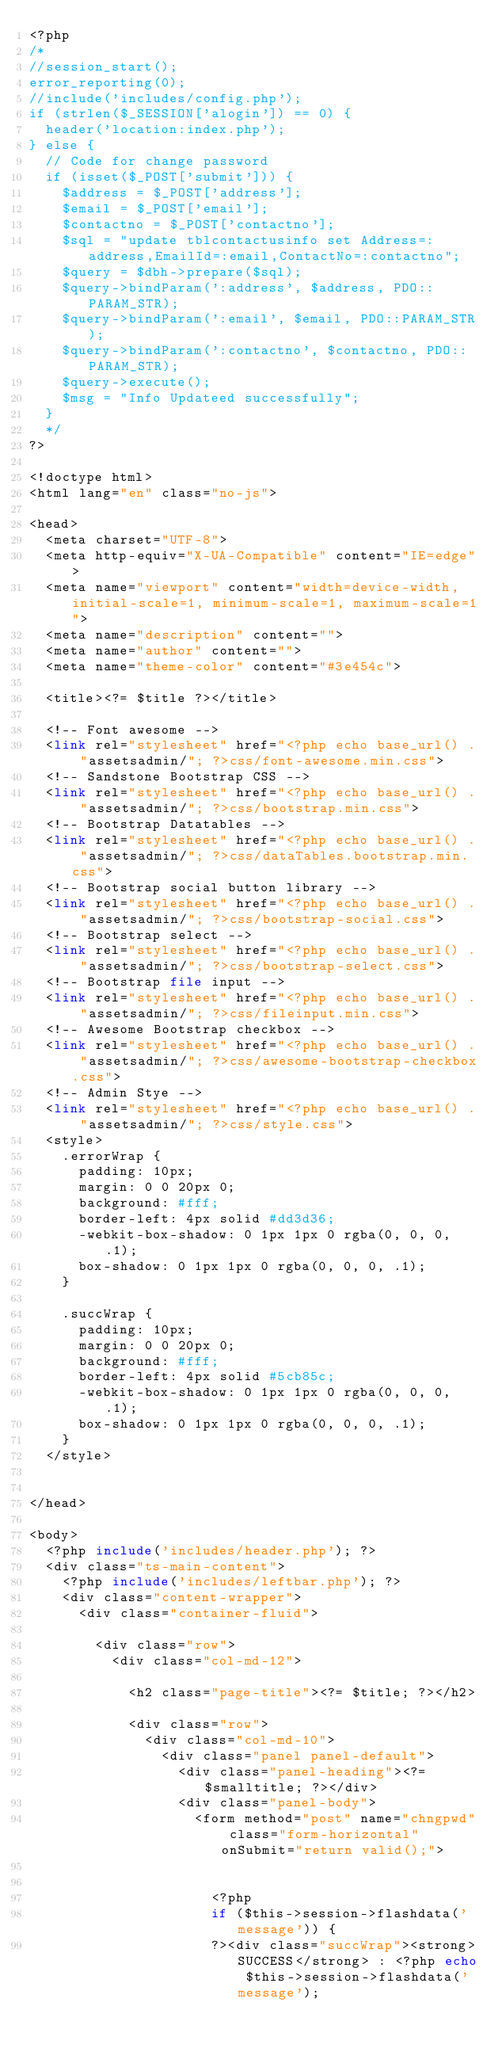Convert code to text. <code><loc_0><loc_0><loc_500><loc_500><_PHP_><?php
/*
//session_start();
error_reporting(0);
//include('includes/config.php');
if (strlen($_SESSION['alogin']) == 0) {
	header('location:index.php');
} else {
	// Code for change password	
	if (isset($_POST['submit'])) {
		$address = $_POST['address'];
		$email = $_POST['email'];
		$contactno = $_POST['contactno'];
		$sql = "update tblcontactusinfo set Address=:address,EmailId=:email,ContactNo=:contactno";
		$query = $dbh->prepare($sql);
		$query->bindParam(':address', $address, PDO::PARAM_STR);
		$query->bindParam(':email', $email, PDO::PARAM_STR);
		$query->bindParam(':contactno', $contactno, PDO::PARAM_STR);
		$query->execute();
		$msg = "Info Updateed successfully";
	}
	*/
?>

<!doctype html>
<html lang="en" class="no-js">

<head>
	<meta charset="UTF-8">
	<meta http-equiv="X-UA-Compatible" content="IE=edge">
	<meta name="viewport" content="width=device-width, initial-scale=1, minimum-scale=1, maximum-scale=1">
	<meta name="description" content="">
	<meta name="author" content="">
	<meta name="theme-color" content="#3e454c">

	<title><?= $title ?></title>

	<!-- Font awesome -->
	<link rel="stylesheet" href="<?php echo base_url() . "assetsadmin/"; ?>css/font-awesome.min.css">
	<!-- Sandstone Bootstrap CSS -->
	<link rel="stylesheet" href="<?php echo base_url() . "assetsadmin/"; ?>css/bootstrap.min.css">
	<!-- Bootstrap Datatables -->
	<link rel="stylesheet" href="<?php echo base_url() . "assetsadmin/"; ?>css/dataTables.bootstrap.min.css">
	<!-- Bootstrap social button library -->
	<link rel="stylesheet" href="<?php echo base_url() . "assetsadmin/"; ?>css/bootstrap-social.css">
	<!-- Bootstrap select -->
	<link rel="stylesheet" href="<?php echo base_url() . "assetsadmin/"; ?>css/bootstrap-select.css">
	<!-- Bootstrap file input -->
	<link rel="stylesheet" href="<?php echo base_url() . "assetsadmin/"; ?>css/fileinput.min.css">
	<!-- Awesome Bootstrap checkbox -->
	<link rel="stylesheet" href="<?php echo base_url() . "assetsadmin/"; ?>css/awesome-bootstrap-checkbox.css">
	<!-- Admin Stye -->
	<link rel="stylesheet" href="<?php echo base_url() . "assetsadmin/"; ?>css/style.css">
	<style>
		.errorWrap {
			padding: 10px;
			margin: 0 0 20px 0;
			background: #fff;
			border-left: 4px solid #dd3d36;
			-webkit-box-shadow: 0 1px 1px 0 rgba(0, 0, 0, .1);
			box-shadow: 0 1px 1px 0 rgba(0, 0, 0, .1);
		}

		.succWrap {
			padding: 10px;
			margin: 0 0 20px 0;
			background: #fff;
			border-left: 4px solid #5cb85c;
			-webkit-box-shadow: 0 1px 1px 0 rgba(0, 0, 0, .1);
			box-shadow: 0 1px 1px 0 rgba(0, 0, 0, .1);
		}
	</style>


</head>

<body>
	<?php include('includes/header.php'); ?>
	<div class="ts-main-content">
		<?php include('includes/leftbar.php'); ?>
		<div class="content-wrapper">
			<div class="container-fluid">

				<div class="row">
					<div class="col-md-12">

						<h2 class="page-title"><?= $title; ?></h2>

						<div class="row">
							<div class="col-md-10">
								<div class="panel panel-default">
									<div class="panel-heading"><?= $smalltitle; ?></div>
									<div class="panel-body">
										<form method="post" name="chngpwd" class="form-horizontal" onSubmit="return valid();">


											<?php
											if ($this->session->flashdata('message')) {
											?><div class="succWrap"><strong>SUCCESS</strong> : <?php echo $this->session->flashdata('message');</code> 